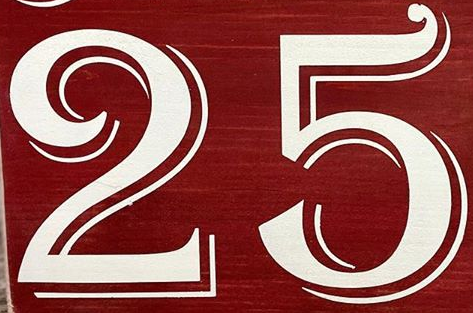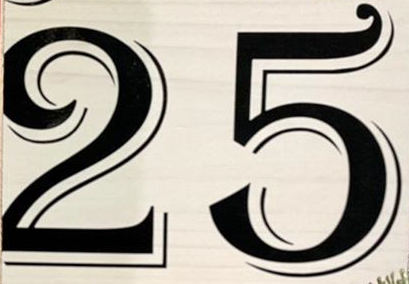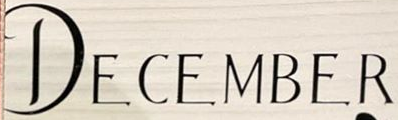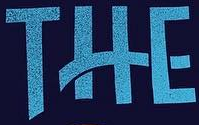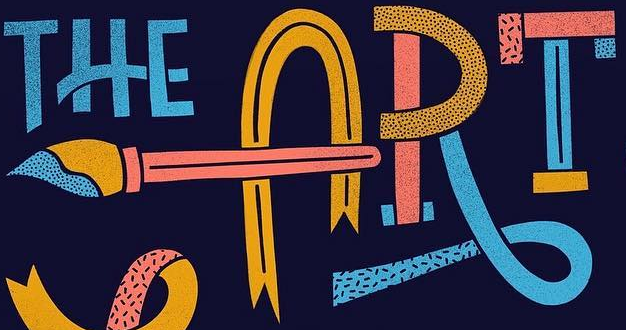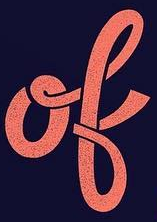Identify the words shown in these images in order, separated by a semicolon. 25; 25; DECEMBER; THE; ART; ok 